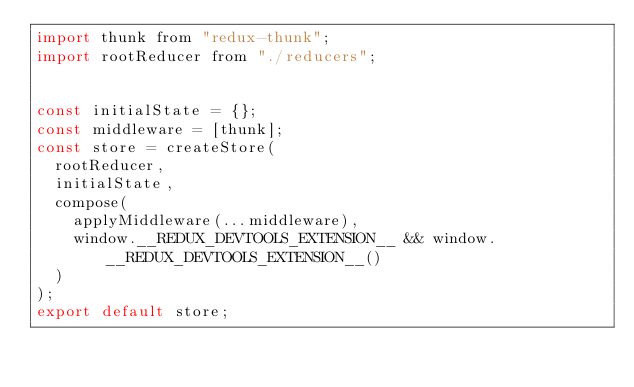<code> <loc_0><loc_0><loc_500><loc_500><_JavaScript_>import thunk from "redux-thunk";
import rootReducer from "./reducers";


const initialState = {};
const middleware = [thunk];
const store = createStore(
  rootReducer,
  initialState,
  compose(
    applyMiddleware(...middleware),
    window.__REDUX_DEVTOOLS_EXTENSION__ && window.__REDUX_DEVTOOLS_EXTENSION__()
  )
);
export default store;</code> 